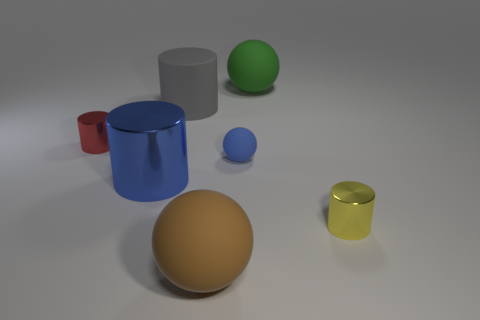Add 3 big cyan metallic cubes. How many objects exist? 10 Subtract all gray spheres. Subtract all green blocks. How many spheres are left? 3 Subtract all spheres. How many objects are left? 4 Subtract 0 purple blocks. How many objects are left? 7 Subtract all big gray objects. Subtract all tiny blue rubber things. How many objects are left? 5 Add 7 gray cylinders. How many gray cylinders are left? 8 Add 4 large brown metallic objects. How many large brown metallic objects exist? 4 